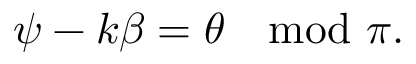Convert formula to latex. <formula><loc_0><loc_0><loc_500><loc_500>\psi - k \beta = \theta \mod \pi .</formula> 